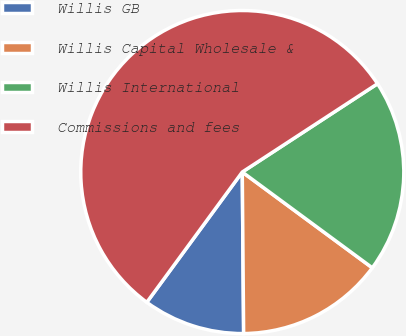Convert chart to OTSL. <chart><loc_0><loc_0><loc_500><loc_500><pie_chart><fcel>Willis GB<fcel>Willis Capital Wholesale &<fcel>Willis International<fcel>Commissions and fees<nl><fcel>10.2%<fcel>14.76%<fcel>19.31%<fcel>55.73%<nl></chart> 